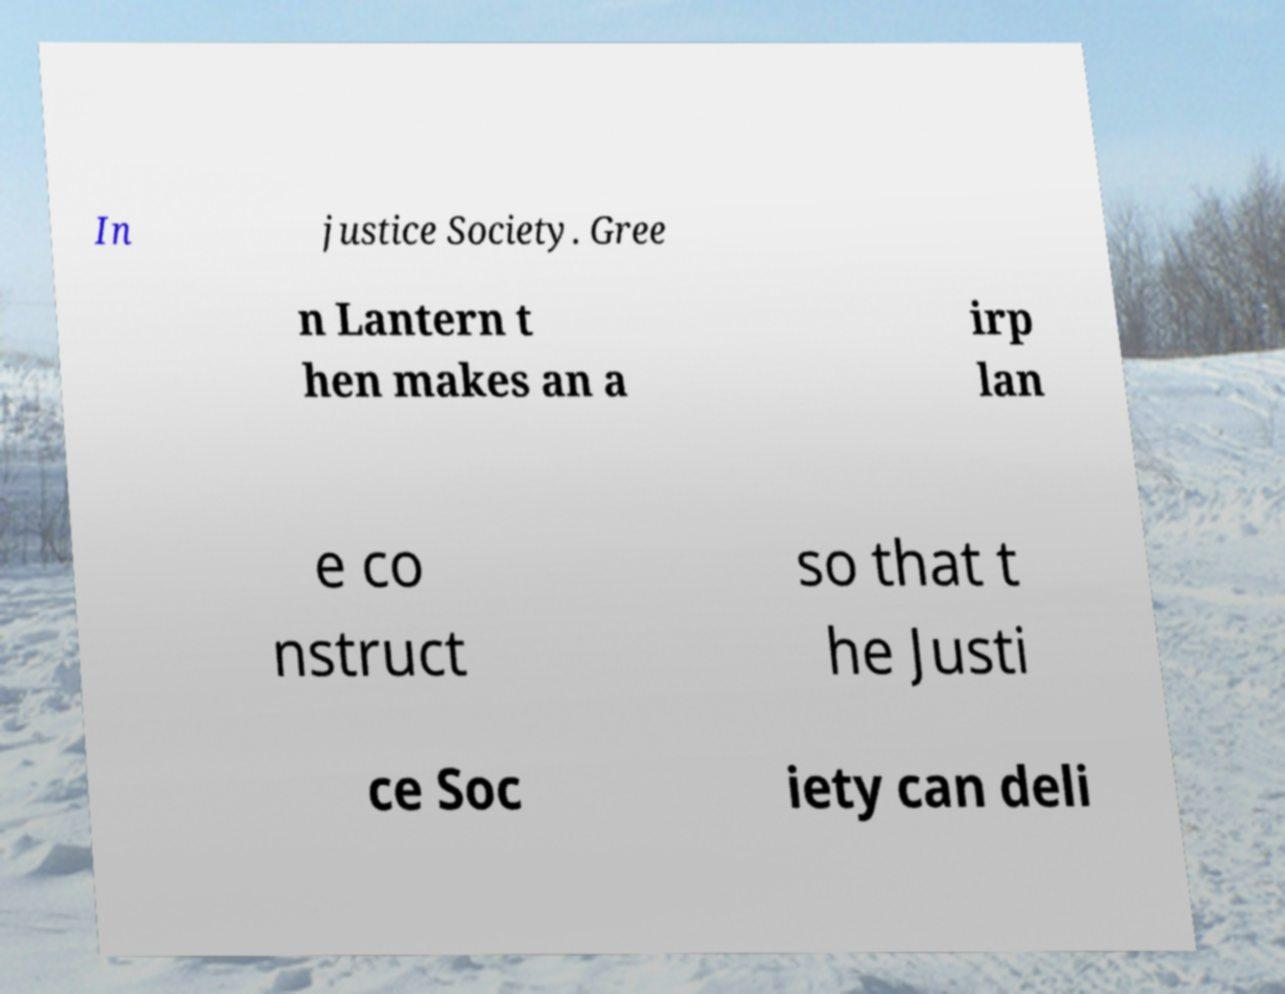Please read and relay the text visible in this image. What does it say? In justice Society. Gree n Lantern t hen makes an a irp lan e co nstruct so that t he Justi ce Soc iety can deli 